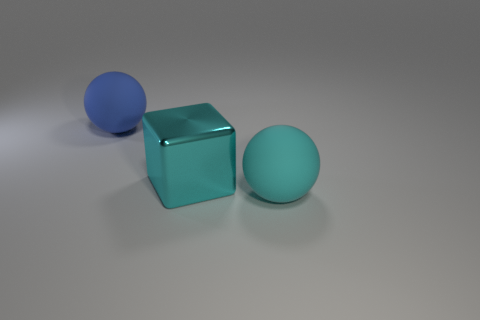There is a cyan thing that is the same size as the block; what is its shape?
Ensure brevity in your answer.  Sphere. What material is the blue object?
Make the answer very short. Rubber. What is the size of the ball on the right side of the cyan object that is behind the big matte ball that is on the right side of the cyan block?
Your answer should be compact. Large. What number of matte things are cyan balls or large blue spheres?
Give a very brief answer. 2. The shiny object is what size?
Make the answer very short. Large. What number of things are either small matte spheres or matte things behind the big cyan metallic object?
Your answer should be compact. 1. What number of other things are the same color as the metallic thing?
Your answer should be compact. 1. What number of other things are there of the same material as the big blue sphere
Your answer should be compact. 1. Is the number of matte balls that are right of the cyan matte thing the same as the number of cyan things behind the big blue object?
Your answer should be very brief. Yes. There is a big matte sphere to the right of the rubber ball left of the sphere to the right of the big block; what color is it?
Give a very brief answer. Cyan. 